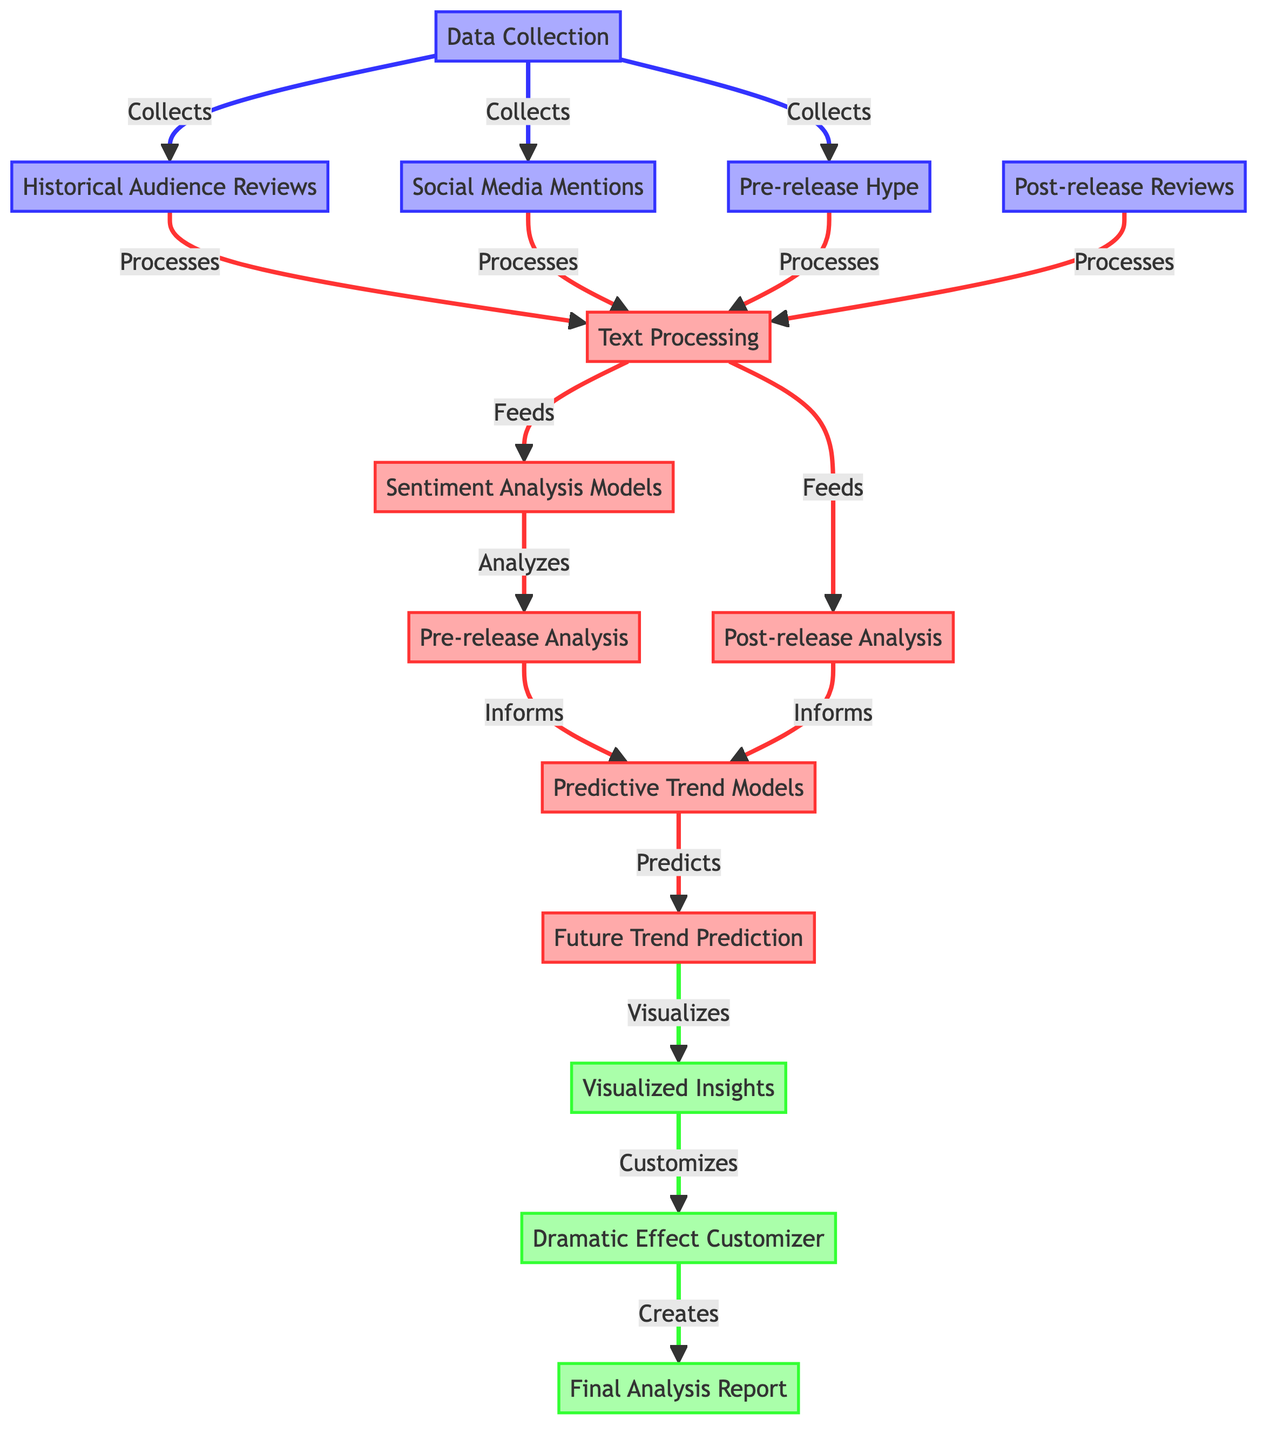What's the first step in data collection? The first step in data collection involves gathering historical audience reviews, social media mentions, and pre-release hype. This is indicated by the arrows leading out of the data collection node.
Answer: Historical Audience Reviews, Social Media Mentions, Pre-release Hype How many analysis processes are shown in the diagram? There are three analysis processes depicted in the diagram: pre-release analysis, post-release analysis, and predictive models. Each of these is clearly labeled and connected in the process section.
Answer: Three Which models analyze the pre-release data? The sentiment analysis models analyze the pre-release data, as indicated by the flow of arrows from the text processing node to the pre-release analysis node.
Answer: Sentiment Analysis Models What does the predictive models inform? The predictive models are informed by both the pre-release analysis and the post-release analysis, as shown by the arrows leading to the predictive models node from each of these analysis processes.
Answer: Pre-release Analysis and Post-release Analysis What is the final output created in the diagram? The final output created in the diagram is the final analysis report, which is the outcome of customization from the visualized insights and the dramatic effect customizer.
Answer: Final Analysis Report Which node visualizes future trends? The node responsible for visualizing future trends is the "Future Trend Prediction" node, as it is connected to the predictive models and leads to the visualized insights.
Answer: Visualized Insights How is the dramatic effect utilized in the process? The dramatic effect is utilized through the dramatic effect customizer, which receives insights from the visualized insights node, indicating an intention to enhance dramatic storytelling.
Answer: Dramatic Effect Customizer What type of data is processed for post-release analysis? The post-release analysis processes post-release reviews, which is indicated by the distinct arrow pointing from post-release reviews to the text processing node.
Answer: Post-release Reviews 